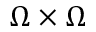Convert formula to latex. <formula><loc_0><loc_0><loc_500><loc_500>\Omega \times \Omega</formula> 